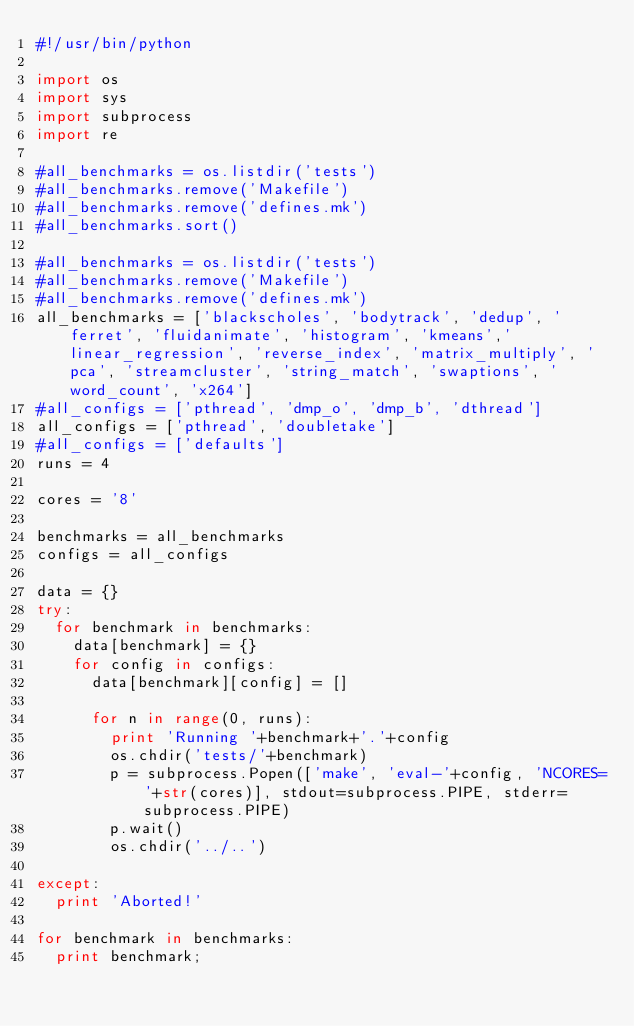Convert code to text. <code><loc_0><loc_0><loc_500><loc_500><_Python_>#!/usr/bin/python

import os
import sys
import subprocess
import re

#all_benchmarks = os.listdir('tests')
#all_benchmarks.remove('Makefile')
#all_benchmarks.remove('defines.mk')
#all_benchmarks.sort()

#all_benchmarks = os.listdir('tests')
#all_benchmarks.remove('Makefile')
#all_benchmarks.remove('defines.mk')
all_benchmarks = ['blackscholes', 'bodytrack', 'dedup', 'ferret', 'fluidanimate', 'histogram', 'kmeans','linear_regression', 'reverse_index', 'matrix_multiply', 'pca', 'streamcluster', 'string_match', 'swaptions', 'word_count', 'x264'] 
#all_configs = ['pthread', 'dmp_o', 'dmp_b', 'dthread']
all_configs = ['pthread', 'doubletake']
#all_configs = ['defaults']
runs = 4

cores = '8'

benchmarks = all_benchmarks
configs = all_configs

data = {}
try:
	for benchmark in benchmarks:
		data[benchmark] = {}
		for config in configs:
			data[benchmark][config] = []
	
			for n in range(0, runs):
				print 'Running '+benchmark+'.'+config
				os.chdir('tests/'+benchmark)
				p = subprocess.Popen(['make', 'eval-'+config, 'NCORES='+str(cores)], stdout=subprocess.PIPE, stderr=subprocess.PIPE)
				p.wait()
				os.chdir('../..')

except:
	print 'Aborted!'
	
for benchmark in benchmarks:
	print benchmark;
</code> 